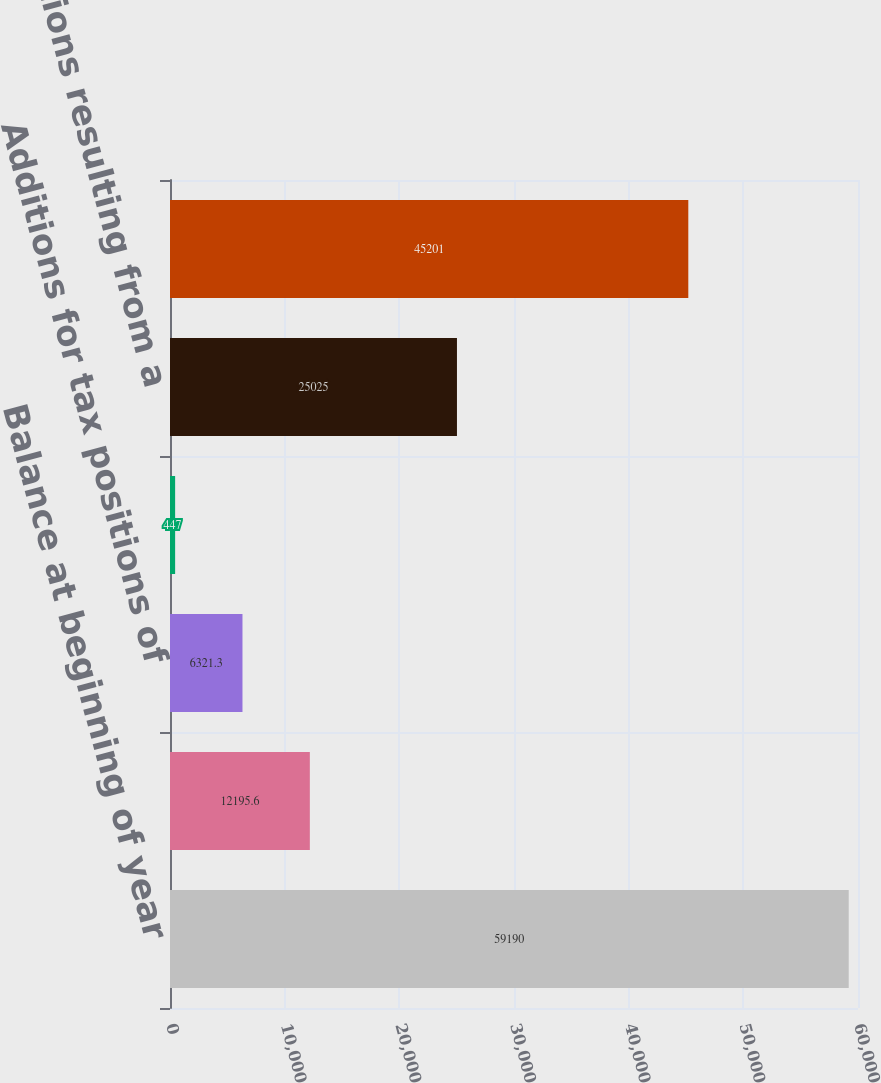Convert chart to OTSL. <chart><loc_0><loc_0><loc_500><loc_500><bar_chart><fcel>Balance at beginning of year<fcel>Additions based on tax<fcel>Additions for tax positions of<fcel>Settlements<fcel>Reductions resulting from a<fcel>Balance at end of year<nl><fcel>59190<fcel>12195.6<fcel>6321.3<fcel>447<fcel>25025<fcel>45201<nl></chart> 